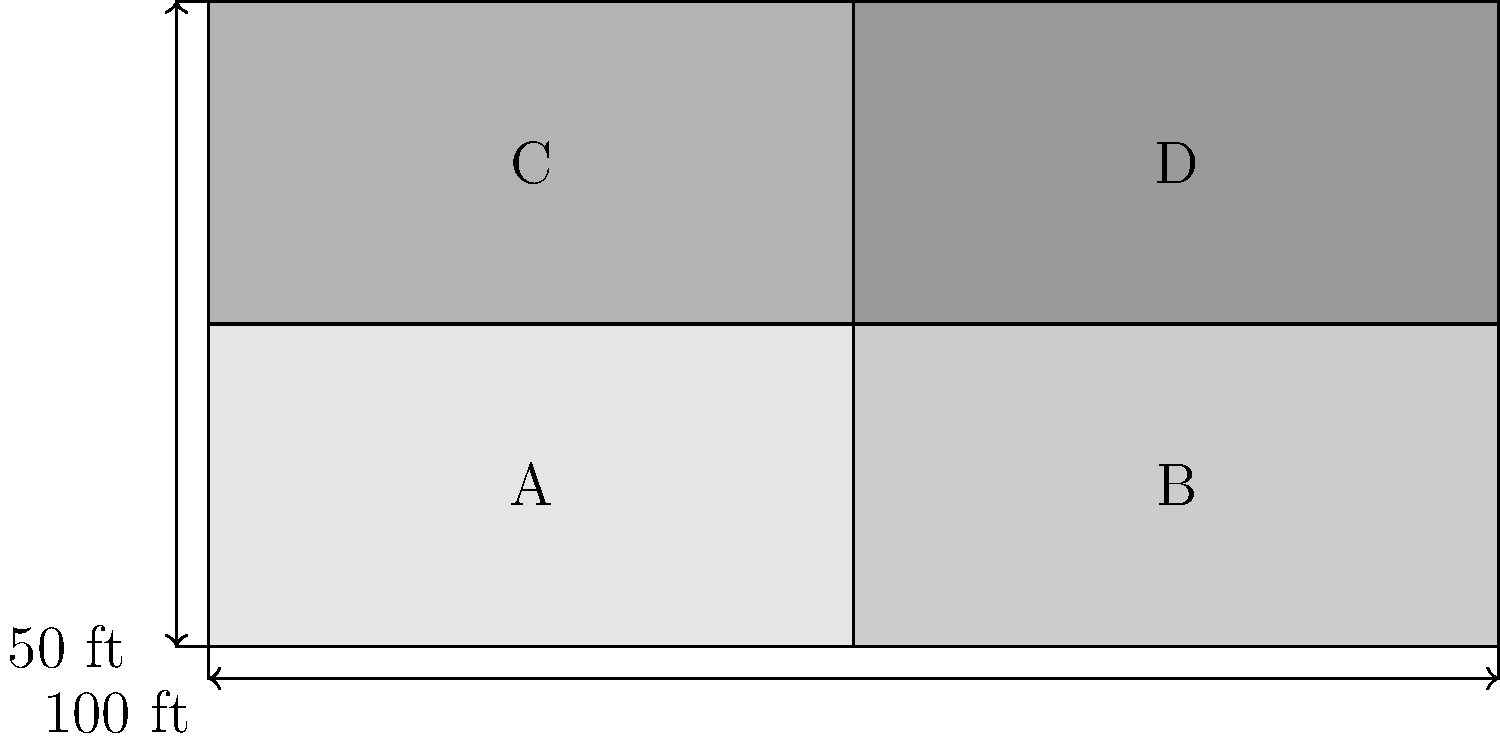In the Michigan Stadium seating chart shown above, sections A, B, C, and D represent different seating zones. If the total area of sections A and C is 7,500 square feet, what is the total area of all four sections combined? Let's approach this step-by-step:

1) First, we need to understand what the diagram shows:
   - The stadium is divided into four sections: A, B, C, and D
   - The total width is 200 ft
   - The total height is 100 ft
   - Each section is a rectangle

2) We're told that the total area of sections A and C is 7,500 sq ft.
   These two sections together form a rectangle that is 100 ft wide and 50 ft tall.

3) We can calculate the area of A and C:
   Area of A + C = 100 ft × 50 ft = 5,000 sq ft

4) However, we're told this area is actually 7,500 sq ft. This means our scale is off.
   We need to find the scale factor:
   Scale factor = 7,500 ÷ 5,000 = 1.5

5) Now we know that all dimensions in the real stadium are 1.5 times larger than in our diagram.

6) To find the total area of all sections, let's calculate the real dimensions:
   Real width = 200 ft × 1.5 = 300 ft
   Real height = 100 ft × 1.5 = 150 ft

7) The total area is then:
   Total Area = 300 ft × 150 ft = 45,000 sq ft

Therefore, the total area of all four sections combined is 45,000 square feet.
Answer: 45,000 sq ft 